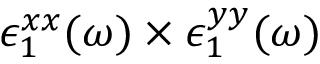<formula> <loc_0><loc_0><loc_500><loc_500>\epsilon _ { 1 } ^ { x x } ( \omega ) \times \epsilon _ { 1 } ^ { y y } ( \omega )</formula> 